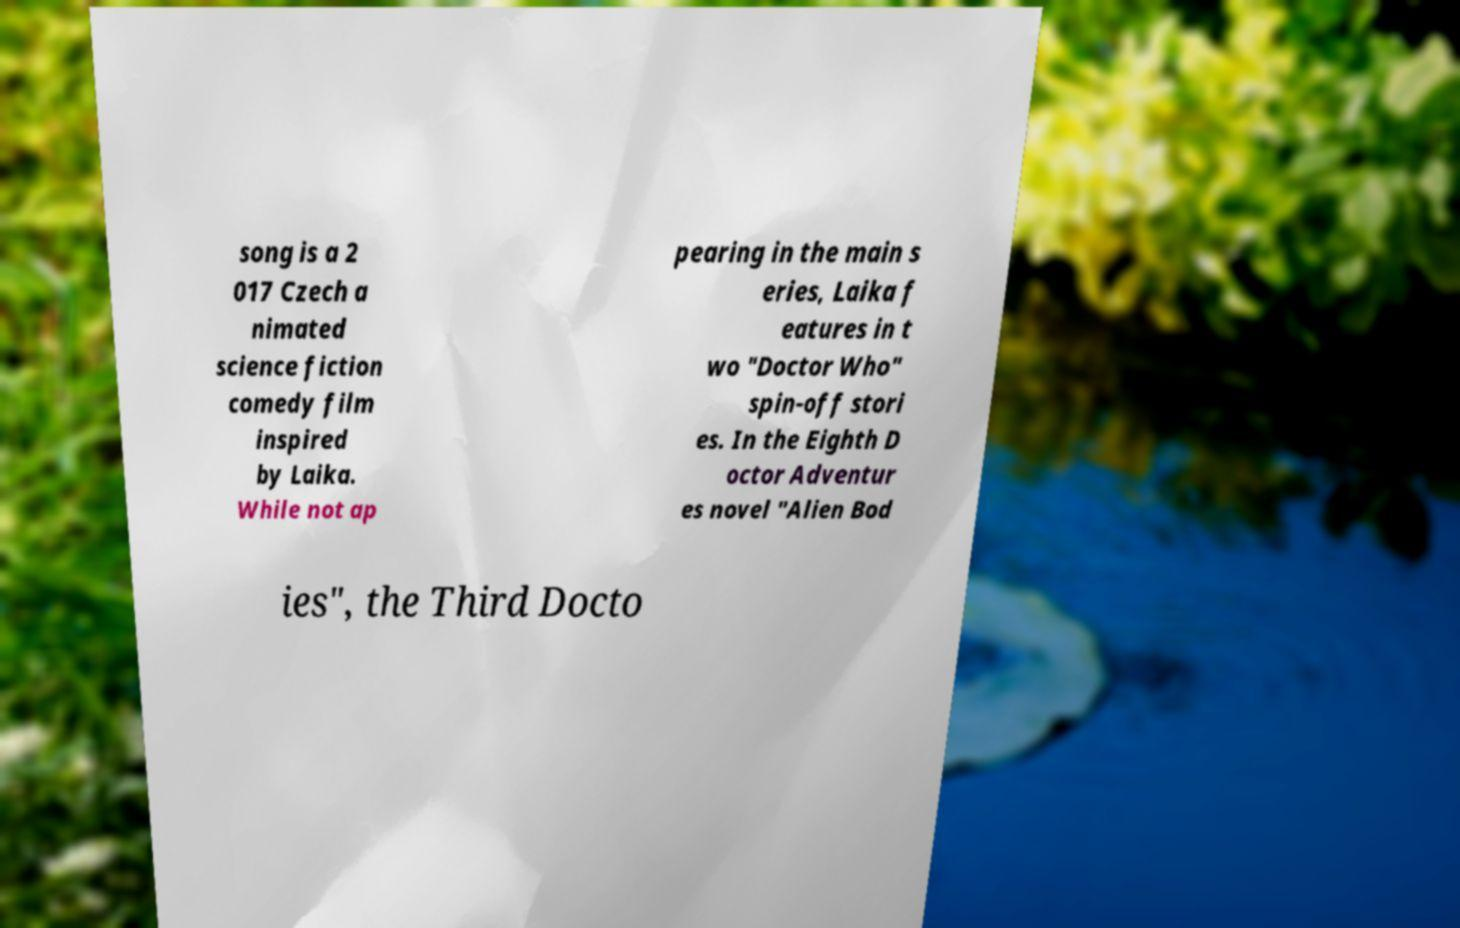Could you extract and type out the text from this image? song is a 2 017 Czech a nimated science fiction comedy film inspired by Laika. While not ap pearing in the main s eries, Laika f eatures in t wo "Doctor Who" spin-off stori es. In the Eighth D octor Adventur es novel "Alien Bod ies", the Third Docto 